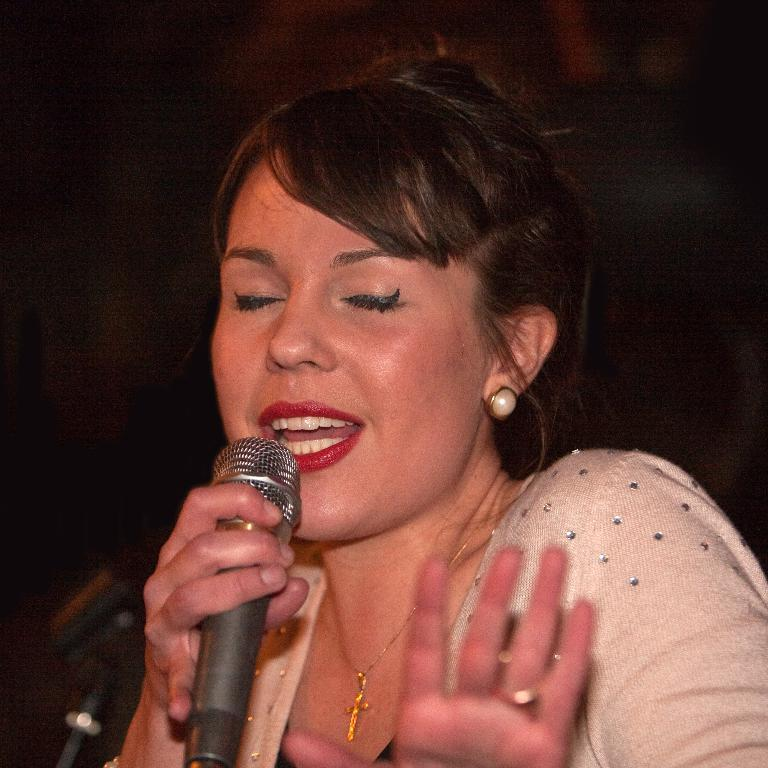What is the main subject of the image? The main subject of the image is a woman. What is the woman wearing? The woman is wearing clothes, a finger ring, a neck chain, and ear studs. What is the woman holding in her hand? The woman is holding a microphone in her hand. What is the woman doing in the image? The woman is singing. What is the color of the background in the image? The background of the image is dark. What type of oatmeal is the woman eating in the image? There is no oatmeal present in the image; the woman is holding a microphone and singing. How does the woman increase her mental capacity while singing in the image? The image does not provide information about the woman's mental capacity or any actions she might be taking to increase it. 